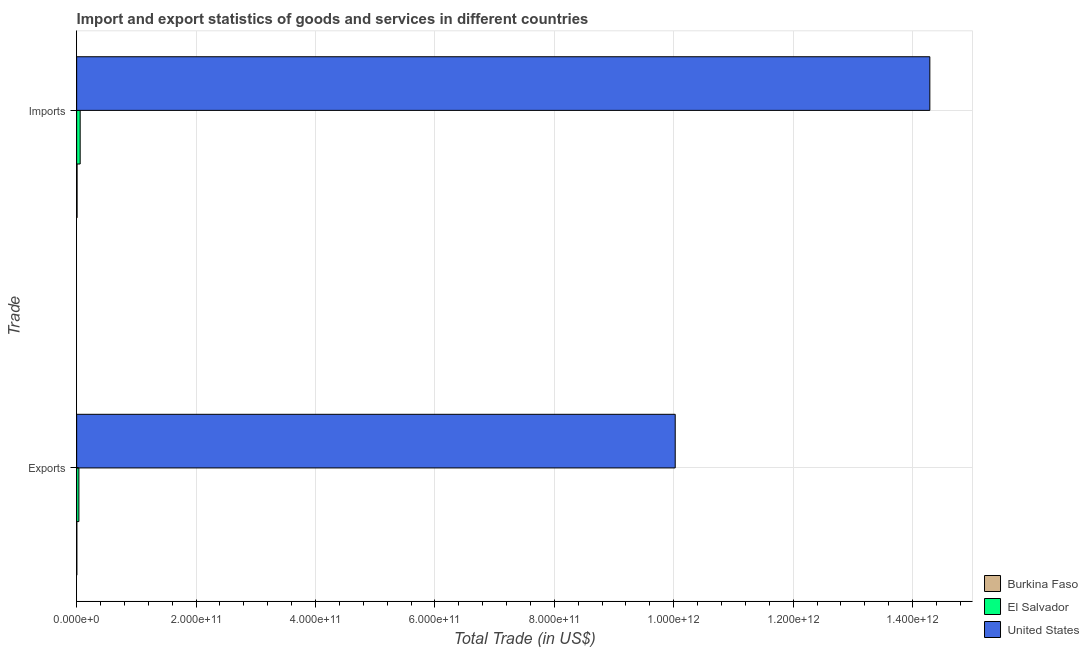How many different coloured bars are there?
Offer a very short reply. 3. Are the number of bars on each tick of the Y-axis equal?
Ensure brevity in your answer.  Yes. How many bars are there on the 2nd tick from the top?
Give a very brief answer. 3. How many bars are there on the 2nd tick from the bottom?
Your response must be concise. 3. What is the label of the 1st group of bars from the top?
Keep it short and to the point. Imports. What is the export of goods and services in United States?
Ensure brevity in your answer.  1.00e+12. Across all countries, what is the maximum export of goods and services?
Provide a short and direct response. 1.00e+12. Across all countries, what is the minimum imports of goods and services?
Your response must be concise. 6.95e+08. In which country was the imports of goods and services minimum?
Your answer should be compact. Burkina Faso. What is the total export of goods and services in the graph?
Offer a terse response. 1.01e+12. What is the difference between the export of goods and services in El Salvador and that in United States?
Make the answer very short. -9.99e+11. What is the difference between the imports of goods and services in El Salvador and the export of goods and services in United States?
Offer a terse response. -9.97e+11. What is the average imports of goods and services per country?
Offer a terse response. 4.79e+11. What is the difference between the imports of goods and services and export of goods and services in Burkina Faso?
Provide a succinct answer. 4.01e+08. What is the ratio of the imports of goods and services in United States to that in El Salvador?
Keep it short and to the point. 243.15. What does the 3rd bar from the top in Exports represents?
Keep it short and to the point. Burkina Faso. What does the 2nd bar from the bottom in Imports represents?
Offer a terse response. El Salvador. How many bars are there?
Offer a very short reply. 6. Are all the bars in the graph horizontal?
Offer a very short reply. Yes. How many countries are there in the graph?
Make the answer very short. 3. What is the difference between two consecutive major ticks on the X-axis?
Your answer should be very brief. 2.00e+11. Does the graph contain any zero values?
Ensure brevity in your answer.  No. How are the legend labels stacked?
Offer a terse response. Vertical. What is the title of the graph?
Provide a short and direct response. Import and export statistics of goods and services in different countries. Does "Cambodia" appear as one of the legend labels in the graph?
Your answer should be very brief. No. What is the label or title of the X-axis?
Your response must be concise. Total Trade (in US$). What is the label or title of the Y-axis?
Ensure brevity in your answer.  Trade. What is the Total Trade (in US$) in Burkina Faso in Exports?
Give a very brief answer. 2.94e+08. What is the Total Trade (in US$) in El Salvador in Exports?
Ensure brevity in your answer.  3.77e+09. What is the Total Trade (in US$) of United States in Exports?
Provide a succinct answer. 1.00e+12. What is the Total Trade (in US$) of Burkina Faso in Imports?
Give a very brief answer. 6.95e+08. What is the Total Trade (in US$) in El Salvador in Imports?
Your answer should be compact. 5.88e+09. What is the Total Trade (in US$) in United States in Imports?
Your response must be concise. 1.43e+12. Across all Trade, what is the maximum Total Trade (in US$) of Burkina Faso?
Provide a short and direct response. 6.95e+08. Across all Trade, what is the maximum Total Trade (in US$) in El Salvador?
Your response must be concise. 5.88e+09. Across all Trade, what is the maximum Total Trade (in US$) in United States?
Make the answer very short. 1.43e+12. Across all Trade, what is the minimum Total Trade (in US$) of Burkina Faso?
Give a very brief answer. 2.94e+08. Across all Trade, what is the minimum Total Trade (in US$) in El Salvador?
Your answer should be very brief. 3.77e+09. Across all Trade, what is the minimum Total Trade (in US$) of United States?
Provide a short and direct response. 1.00e+12. What is the total Total Trade (in US$) in Burkina Faso in the graph?
Provide a succinct answer. 9.90e+08. What is the total Total Trade (in US$) of El Salvador in the graph?
Offer a very short reply. 9.65e+09. What is the total Total Trade (in US$) of United States in the graph?
Your answer should be compact. 2.43e+12. What is the difference between the Total Trade (in US$) of Burkina Faso in Exports and that in Imports?
Ensure brevity in your answer.  -4.01e+08. What is the difference between the Total Trade (in US$) in El Salvador in Exports and that in Imports?
Provide a succinct answer. -2.10e+09. What is the difference between the Total Trade (in US$) of United States in Exports and that in Imports?
Ensure brevity in your answer.  -4.26e+11. What is the difference between the Total Trade (in US$) of Burkina Faso in Exports and the Total Trade (in US$) of El Salvador in Imports?
Give a very brief answer. -5.58e+09. What is the difference between the Total Trade (in US$) in Burkina Faso in Exports and the Total Trade (in US$) in United States in Imports?
Give a very brief answer. -1.43e+12. What is the difference between the Total Trade (in US$) in El Salvador in Exports and the Total Trade (in US$) in United States in Imports?
Make the answer very short. -1.43e+12. What is the average Total Trade (in US$) in Burkina Faso per Trade?
Make the answer very short. 4.95e+08. What is the average Total Trade (in US$) of El Salvador per Trade?
Provide a short and direct response. 4.82e+09. What is the average Total Trade (in US$) of United States per Trade?
Your answer should be compact. 1.22e+12. What is the difference between the Total Trade (in US$) of Burkina Faso and Total Trade (in US$) of El Salvador in Exports?
Offer a terse response. -3.48e+09. What is the difference between the Total Trade (in US$) in Burkina Faso and Total Trade (in US$) in United States in Exports?
Offer a terse response. -1.00e+12. What is the difference between the Total Trade (in US$) in El Salvador and Total Trade (in US$) in United States in Exports?
Offer a very short reply. -9.99e+11. What is the difference between the Total Trade (in US$) of Burkina Faso and Total Trade (in US$) of El Salvador in Imports?
Give a very brief answer. -5.18e+09. What is the difference between the Total Trade (in US$) of Burkina Faso and Total Trade (in US$) of United States in Imports?
Ensure brevity in your answer.  -1.43e+12. What is the difference between the Total Trade (in US$) in El Salvador and Total Trade (in US$) in United States in Imports?
Your response must be concise. -1.42e+12. What is the ratio of the Total Trade (in US$) of Burkina Faso in Exports to that in Imports?
Your answer should be compact. 0.42. What is the ratio of the Total Trade (in US$) of El Salvador in Exports to that in Imports?
Give a very brief answer. 0.64. What is the ratio of the Total Trade (in US$) of United States in Exports to that in Imports?
Make the answer very short. 0.7. What is the difference between the highest and the second highest Total Trade (in US$) in Burkina Faso?
Your answer should be compact. 4.01e+08. What is the difference between the highest and the second highest Total Trade (in US$) in El Salvador?
Ensure brevity in your answer.  2.10e+09. What is the difference between the highest and the second highest Total Trade (in US$) in United States?
Offer a terse response. 4.26e+11. What is the difference between the highest and the lowest Total Trade (in US$) in Burkina Faso?
Your answer should be very brief. 4.01e+08. What is the difference between the highest and the lowest Total Trade (in US$) in El Salvador?
Ensure brevity in your answer.  2.10e+09. What is the difference between the highest and the lowest Total Trade (in US$) in United States?
Your answer should be very brief. 4.26e+11. 